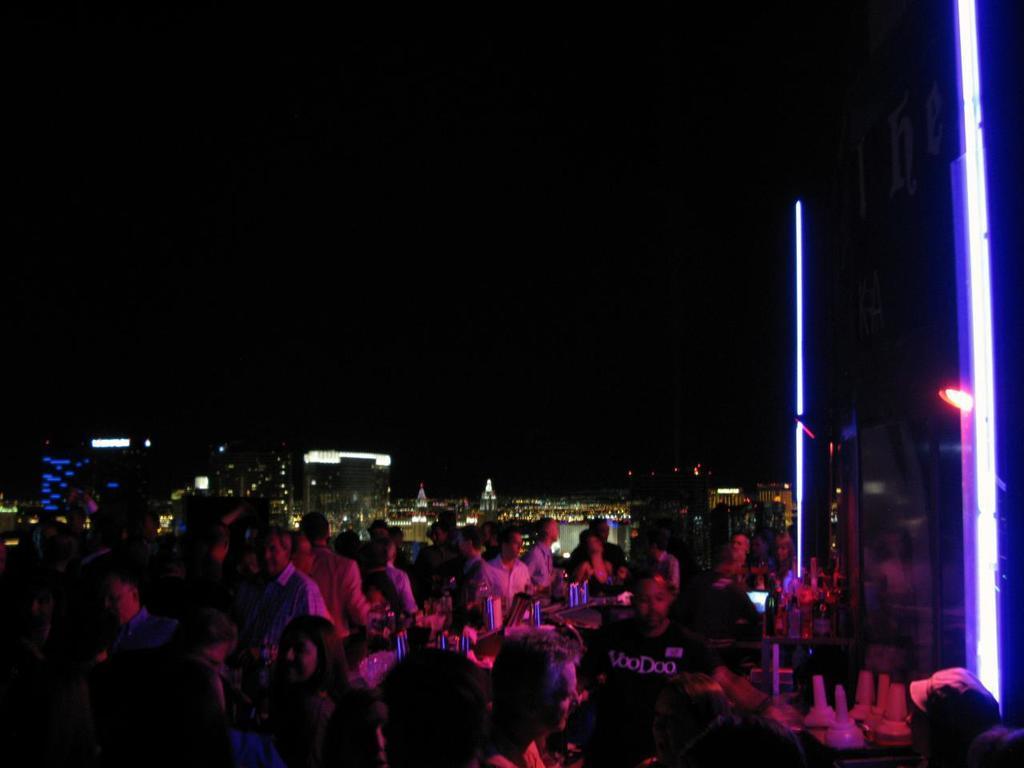How would you summarize this image in a sentence or two? The image is taken in a open bar. In the image there are people, desk, bottles, light and many other objects. In the background there are buildings, skyscrapers and lights. At the top it is sky, sky is dark. 